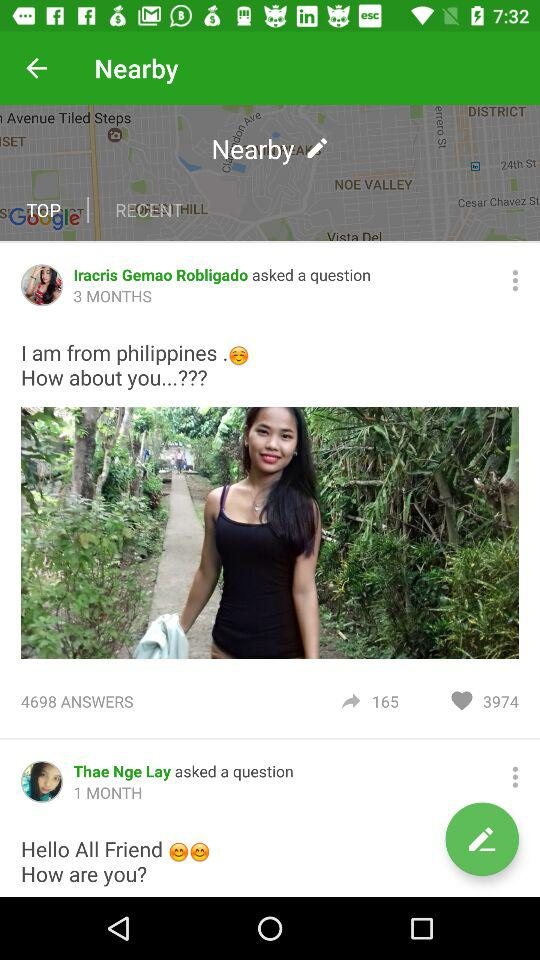When did Thae Nge Lay ask the question? Thae Nge Lay asked the question 1 month ago. 